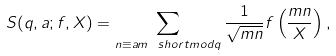<formula> <loc_0><loc_0><loc_500><loc_500>S ( q , a ; f , X ) = \sum _ { n \equiv a m \ s h o r t m o d { q } } \frac { 1 } { \sqrt { m n } } f \left ( \frac { m n } { X } \right ) ,</formula> 